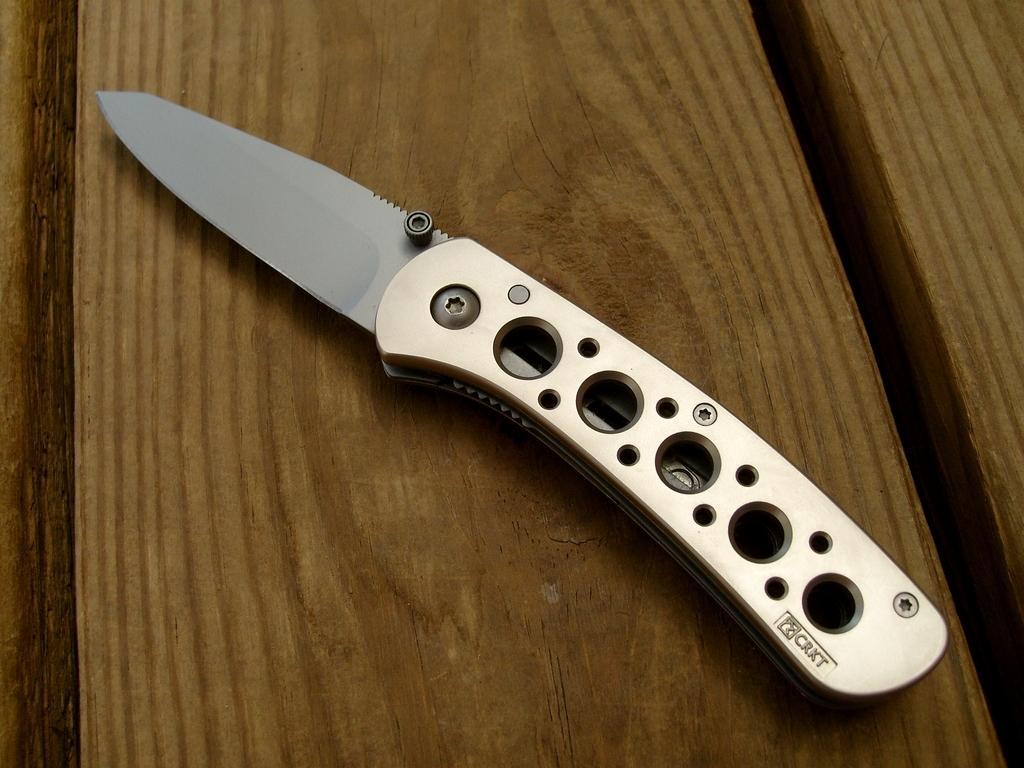Please provide a concise description of this image. In this image there is a metal knife on the wooden table. 